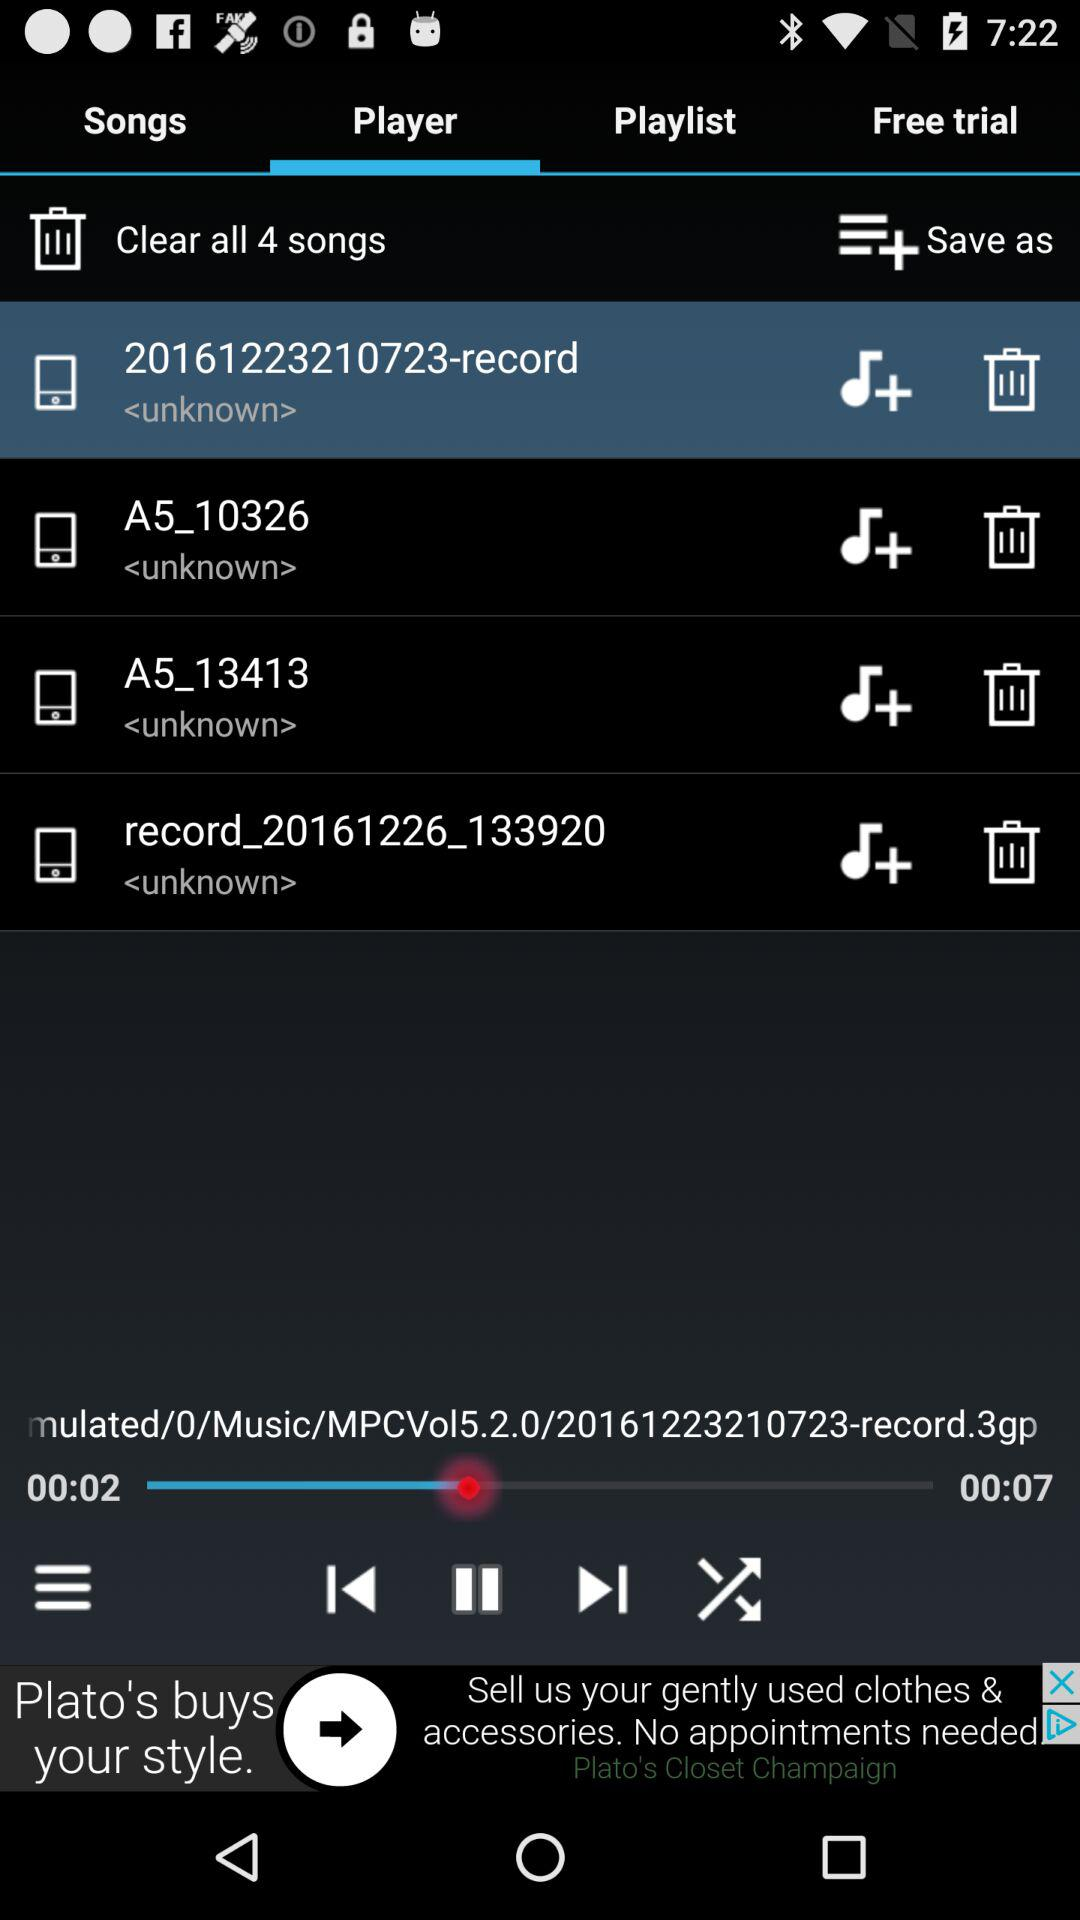How long is the current song?
Answer the question using a single word or phrase. 00:07 